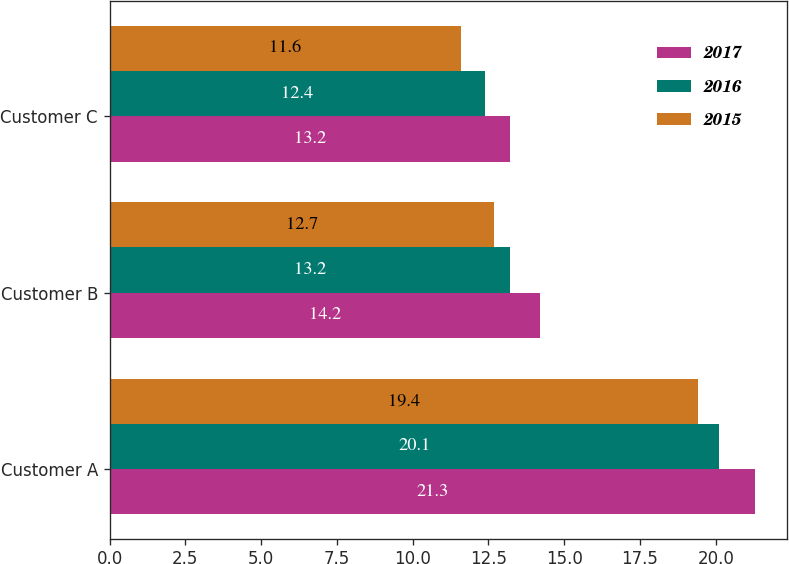<chart> <loc_0><loc_0><loc_500><loc_500><stacked_bar_chart><ecel><fcel>Customer A<fcel>Customer B<fcel>Customer C<nl><fcel>2017<fcel>21.3<fcel>14.2<fcel>13.2<nl><fcel>2016<fcel>20.1<fcel>13.2<fcel>12.4<nl><fcel>2015<fcel>19.4<fcel>12.7<fcel>11.6<nl></chart> 